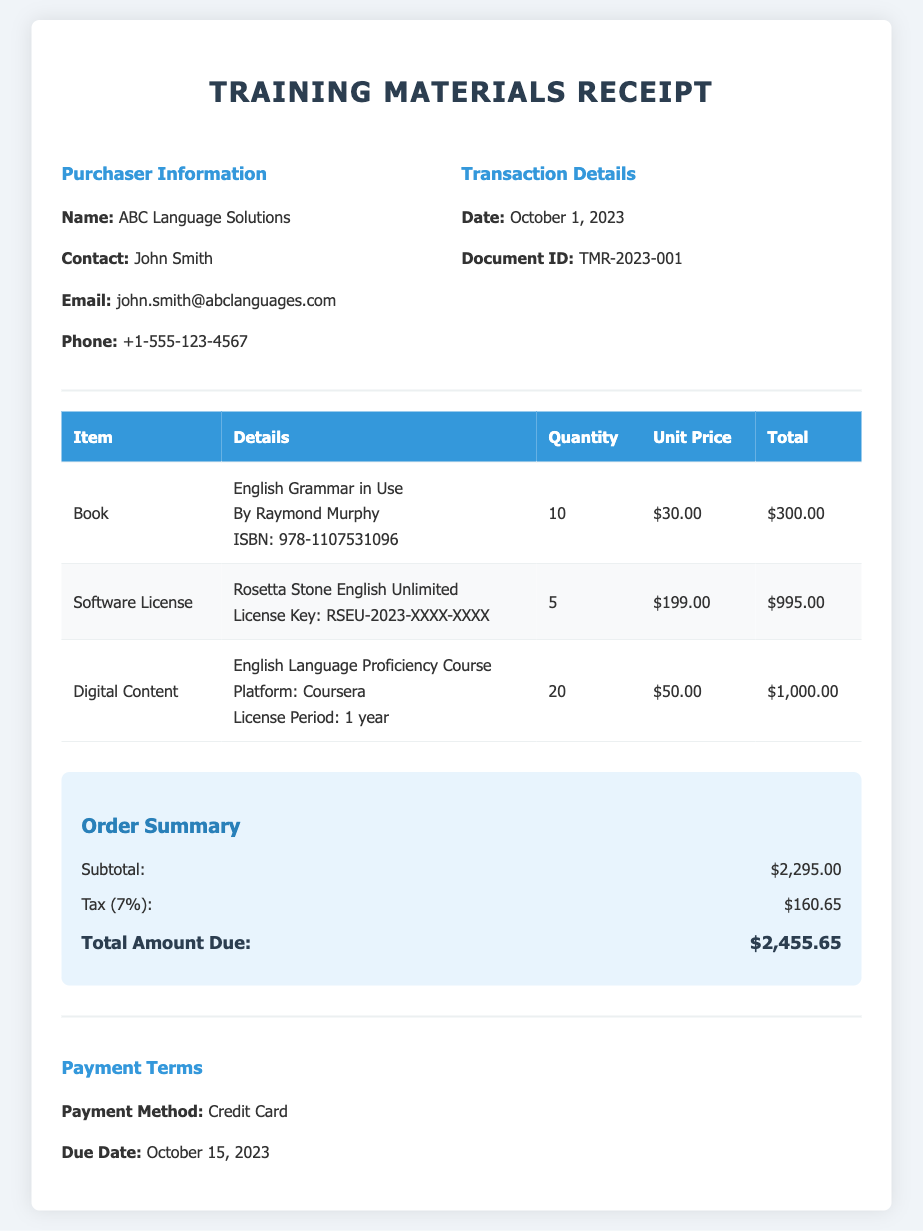What is the name of the purchaser? The document shows the purchaser's name as "ABC Language Solutions."
Answer: ABC Language Solutions Who is the contact person? The contact person for the purchaser is listed as "John Smith."
Answer: John Smith What is the date of the transaction? The date of the transaction appears as "October 1, 2023."
Answer: October 1, 2023 How many units of English Grammar in Use were purchased? The document states that 10 units of "English Grammar in Use" were purchased.
Answer: 10 What is the unit price of the Rosetta Stone English Unlimited license? The unit price for the Rosetta Stone English Unlimited license is mentioned as "$199.00."
Answer: $199.00 What is the subtotal amount according to the order summary? The subtotal amount, as summarized in the document, is "$2,295.00."
Answer: $2,295.00 What is the total amount due? The document lists the total amount due as "$2,455.65."
Answer: $2,455.65 What type of payment method was used? The payment method indicated in the document is "Credit Card."
Answer: Credit Card When is the payment due date? The due date for the payment is specified as "October 15, 2023."
Answer: October 15, 2023 